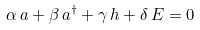Convert formula to latex. <formula><loc_0><loc_0><loc_500><loc_500>\alpha \, a + \beta \, a ^ { \dagger } + \gamma \, h + \delta \, E = 0</formula> 